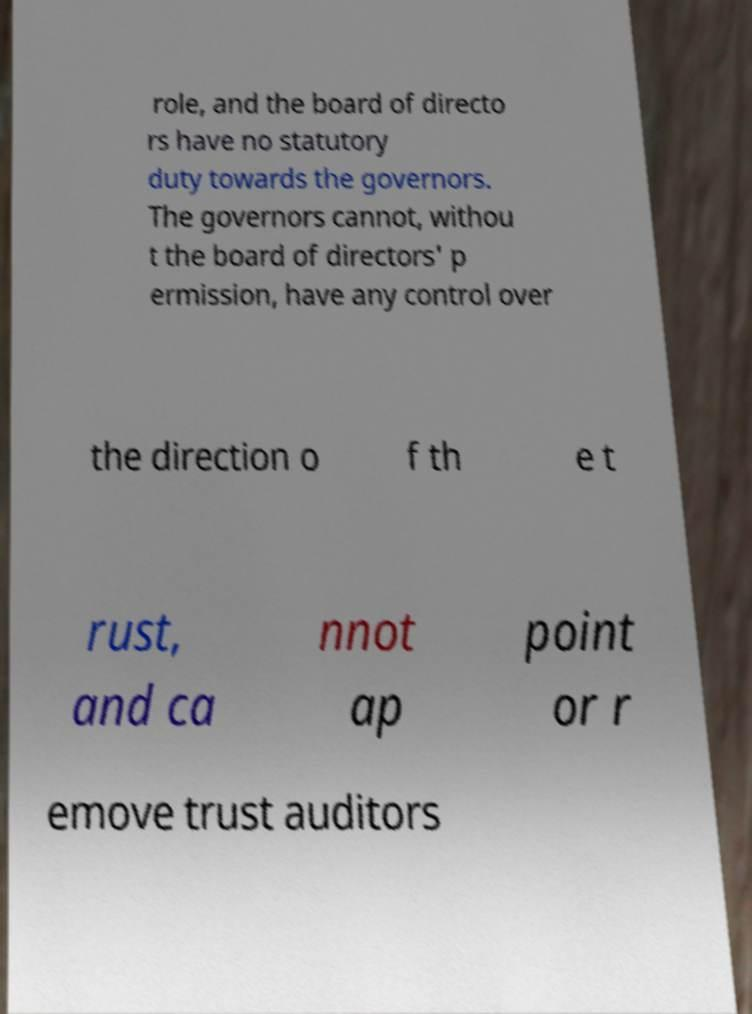Can you read and provide the text displayed in the image?This photo seems to have some interesting text. Can you extract and type it out for me? role, and the board of directo rs have no statutory duty towards the governors. The governors cannot, withou t the board of directors' p ermission, have any control over the direction o f th e t rust, and ca nnot ap point or r emove trust auditors 